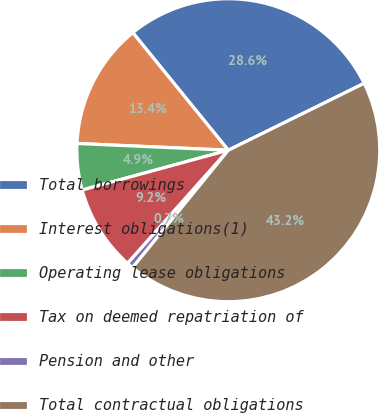<chart> <loc_0><loc_0><loc_500><loc_500><pie_chart><fcel>Total borrowings<fcel>Interest obligations(1)<fcel>Operating lease obligations<fcel>Tax on deemed repatriation of<fcel>Pension and other<fcel>Total contractual obligations<nl><fcel>28.58%<fcel>13.43%<fcel>4.94%<fcel>9.19%<fcel>0.69%<fcel>43.17%<nl></chart> 